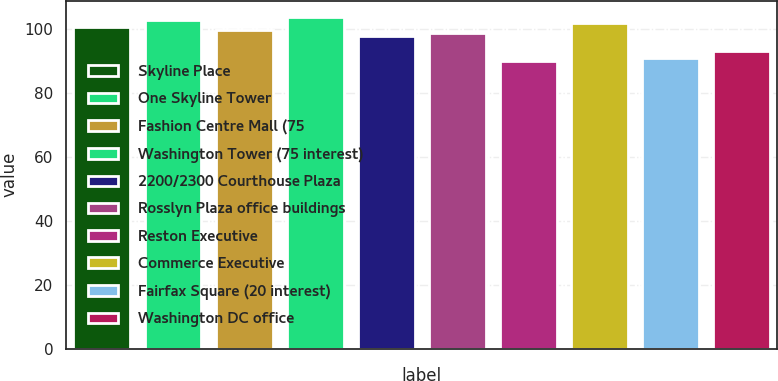Convert chart to OTSL. <chart><loc_0><loc_0><loc_500><loc_500><bar_chart><fcel>Skyline Place<fcel>One Skyline Tower<fcel>Fashion Centre Mall (75<fcel>Washington Tower (75 interest)<fcel>2200/2300 Courthouse Plaza<fcel>Rosslyn Plaza office buildings<fcel>Reston Executive<fcel>Commerce Executive<fcel>Fairfax Square (20 interest)<fcel>Washington DC office<nl><fcel>100.7<fcel>102.7<fcel>99.7<fcel>103.7<fcel>97.7<fcel>98.7<fcel>90<fcel>101.7<fcel>91<fcel>93.2<nl></chart> 